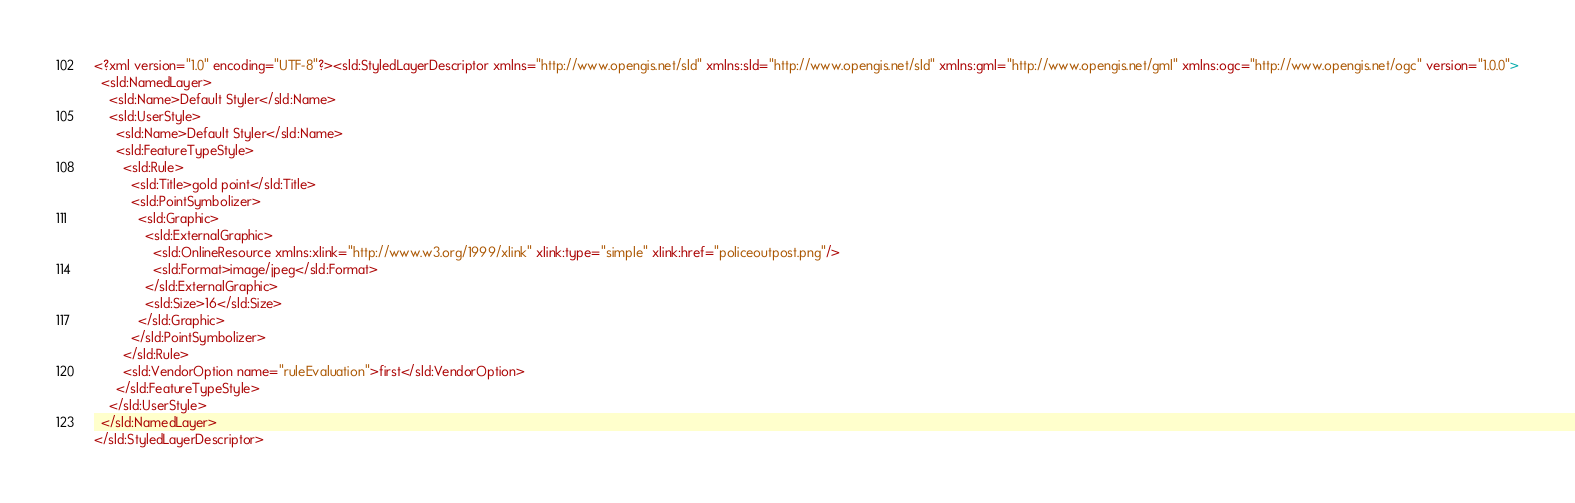<code> <loc_0><loc_0><loc_500><loc_500><_Scheme_><?xml version="1.0" encoding="UTF-8"?><sld:StyledLayerDescriptor xmlns="http://www.opengis.net/sld" xmlns:sld="http://www.opengis.net/sld" xmlns:gml="http://www.opengis.net/gml" xmlns:ogc="http://www.opengis.net/ogc" version="1.0.0">
  <sld:NamedLayer>
    <sld:Name>Default Styler</sld:Name>
    <sld:UserStyle>
      <sld:Name>Default Styler</sld:Name>
      <sld:FeatureTypeStyle>
        <sld:Rule>
          <sld:Title>gold point</sld:Title>
          <sld:PointSymbolizer>
            <sld:Graphic>
              <sld:ExternalGraphic>
                <sld:OnlineResource xmlns:xlink="http://www.w3.org/1999/xlink" xlink:type="simple" xlink:href="policeoutpost.png"/>
                <sld:Format>image/jpeg</sld:Format>
              </sld:ExternalGraphic>
              <sld:Size>16</sld:Size>
            </sld:Graphic>
          </sld:PointSymbolizer>
        </sld:Rule>
        <sld:VendorOption name="ruleEvaluation">first</sld:VendorOption>
      </sld:FeatureTypeStyle>
    </sld:UserStyle>
  </sld:NamedLayer>
</sld:StyledLayerDescriptor>

</code> 